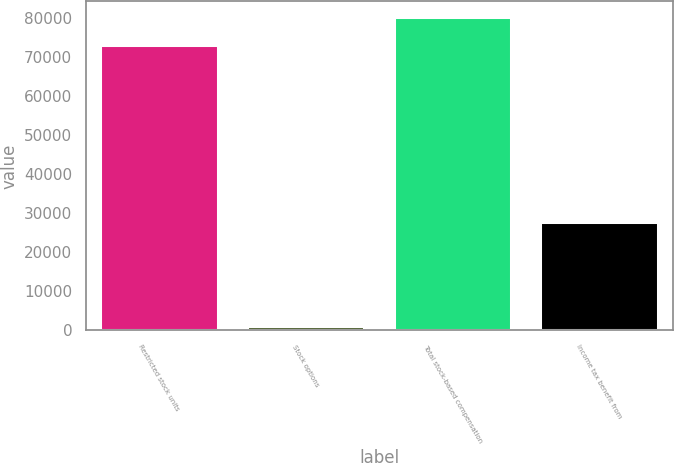Convert chart to OTSL. <chart><loc_0><loc_0><loc_500><loc_500><bar_chart><fcel>Restricted stock units<fcel>Stock options<fcel>Total stock-based compensation<fcel>Income tax benefit from<nl><fcel>73020<fcel>1084<fcel>80322<fcel>27874<nl></chart> 